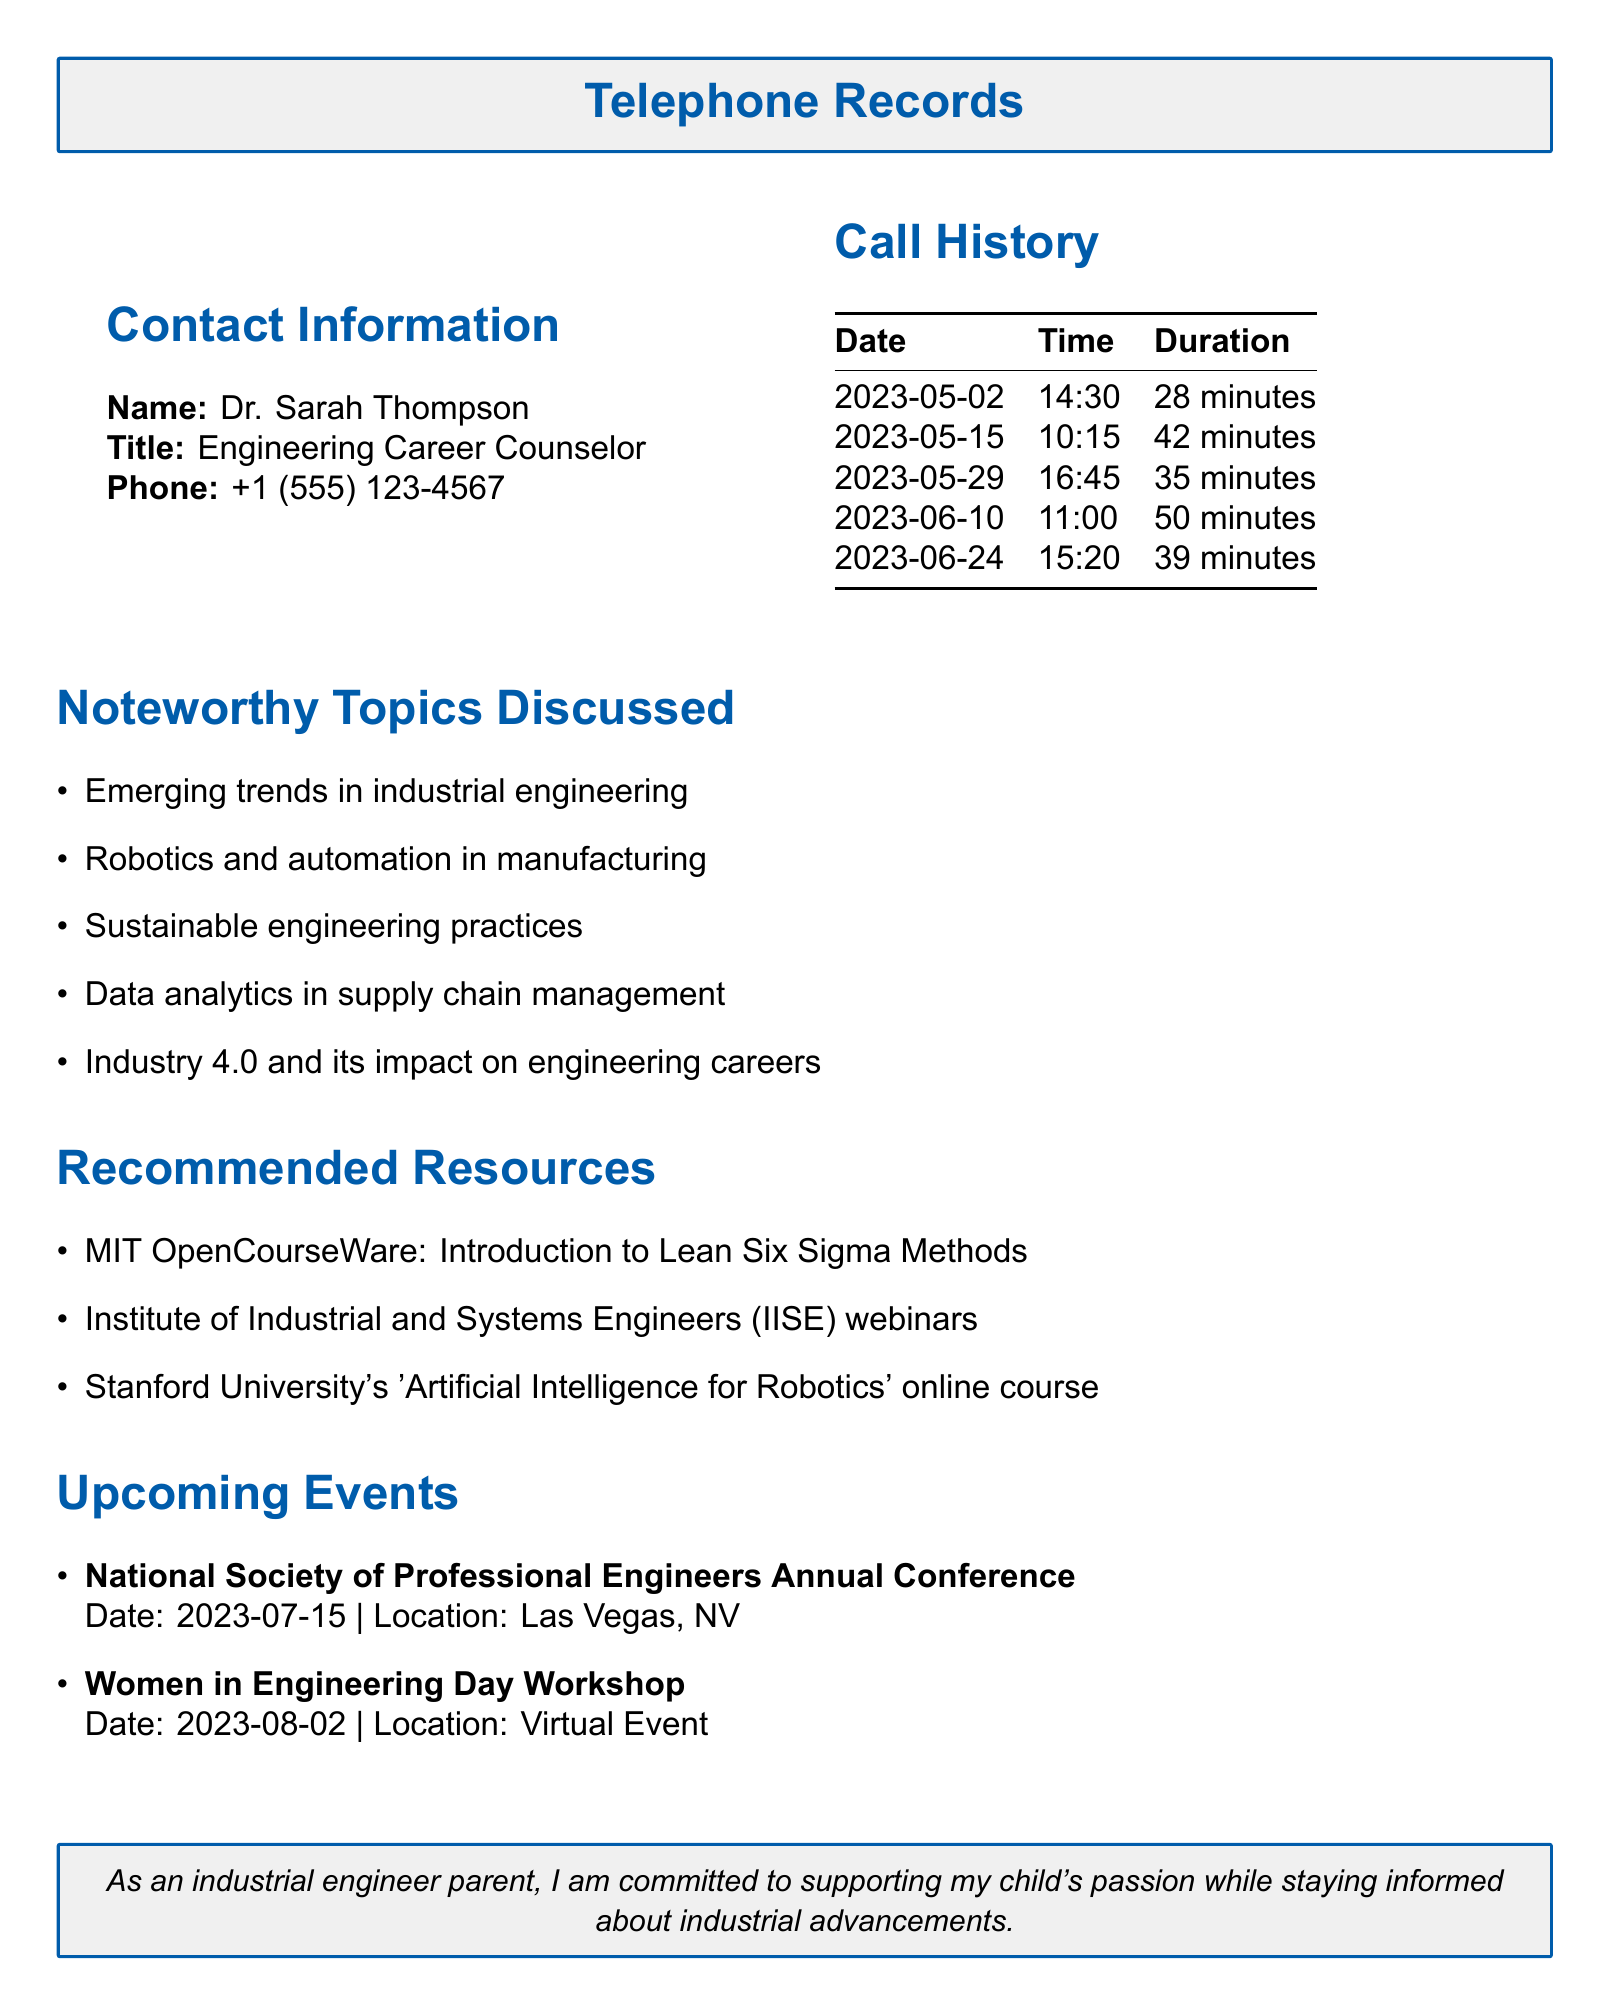What is the name of the career counselor? The name of the career counselor is provided in the contact information section of the document as Dr. Sarah Thompson.
Answer: Dr. Sarah Thompson What is the phone number of the career counselor? The phone number is listed in the contact information section of the document as +1 (555) 123-4567.
Answer: +1 (555) 123-4567 How many minutes was the longest call? The longest call duration is shown in the call history section as 50 minutes.
Answer: 50 minutes What was discussed during the first call? The notable topics discussed are outlined, and the first call date is May 2, 2023. The key topics for that call include emerging trends in industrial engineering.
Answer: Emerging trends in industrial engineering What type of events are listed in the document? The document mentions upcoming events, specifically categorized as professional conferences and workshops focused on engineering.
Answer: Conferences and workshops How many calls were made in June? The call history indicates two calls were made in June, dated June 10 and June 24.
Answer: 2 calls What is one of the recommended resources? The document lists several recommended resources, including MIT OpenCourseWare as one of them.
Answer: MIT OpenCourseWare When is the Women in Engineering Day Workshop scheduled? The document states the date of this workshop as August 2, 2023.
Answer: August 2, 2023 